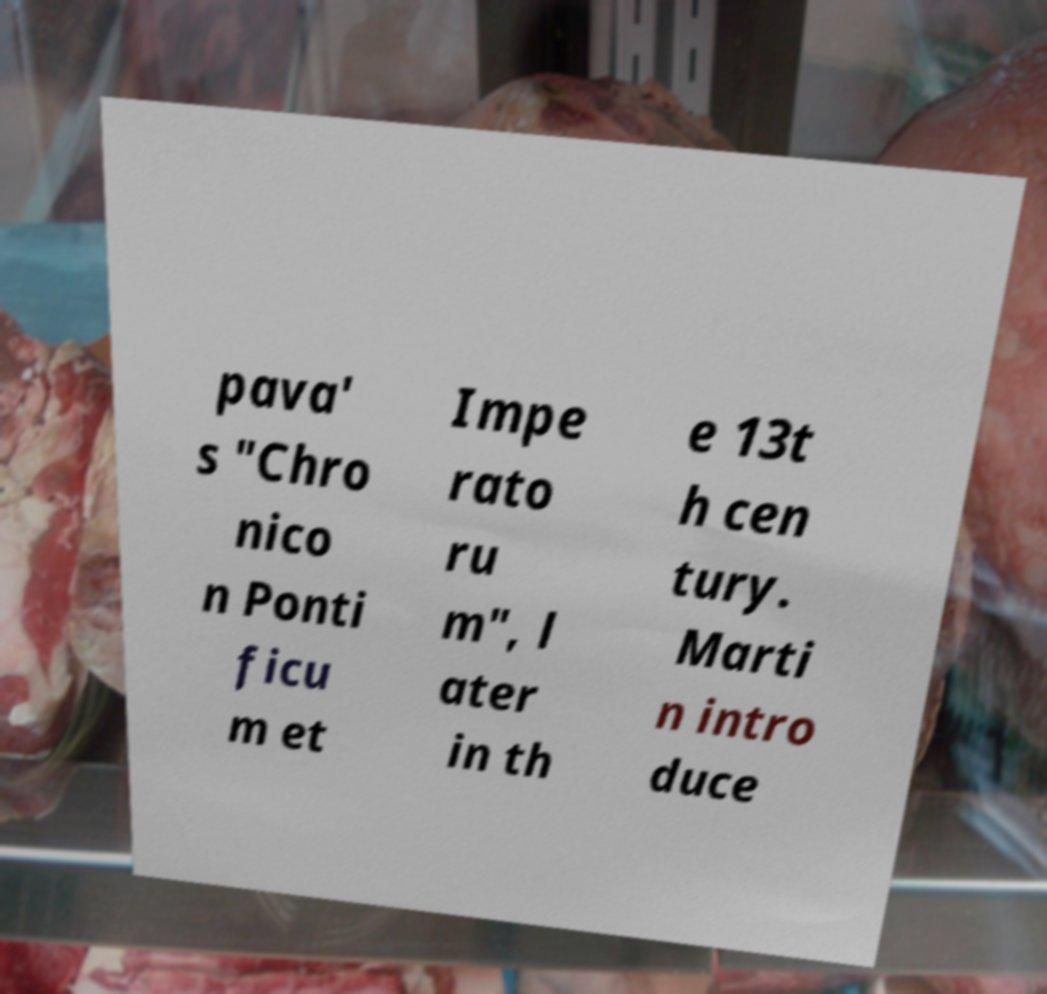Could you extract and type out the text from this image? pava' s "Chro nico n Ponti ficu m et Impe rato ru m", l ater in th e 13t h cen tury. Marti n intro duce 